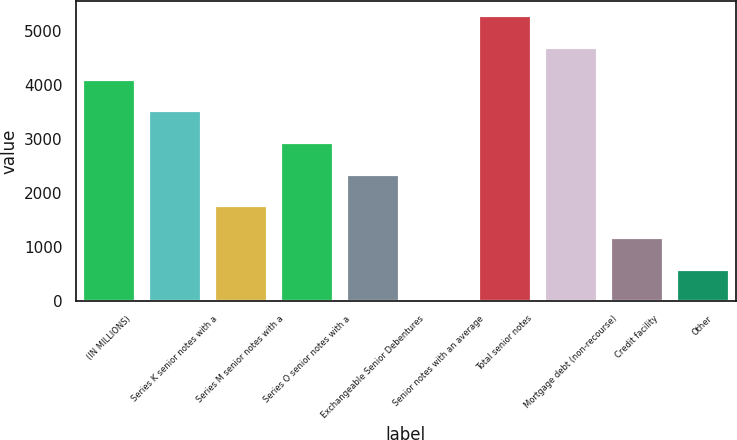<chart> <loc_0><loc_0><loc_500><loc_500><bar_chart><fcel>(IN MILLIONS)<fcel>Series K senior notes with a<fcel>Series M senior notes with a<fcel>Series O senior notes with a<fcel>Exchangeable Senior Debentures<fcel>Senior notes with an average<fcel>Total senior notes<fcel>Mortgage debt (non-recourse)<fcel>Credit facility<fcel>Other<nl><fcel>4118.5<fcel>3532<fcel>1772.5<fcel>2945.5<fcel>2359<fcel>13<fcel>5291.5<fcel>4705<fcel>1186<fcel>599.5<nl></chart> 